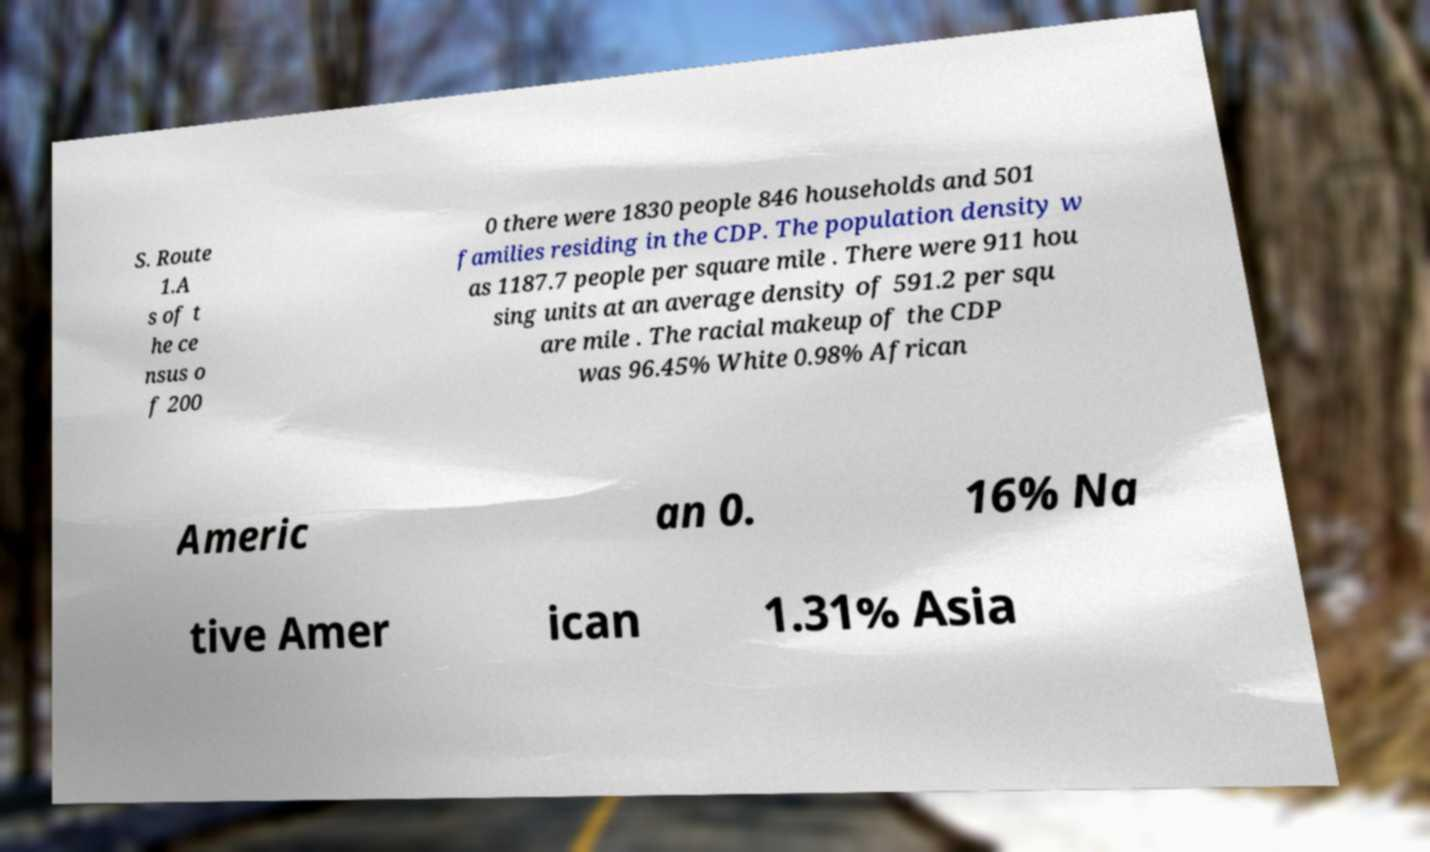Can you read and provide the text displayed in the image?This photo seems to have some interesting text. Can you extract and type it out for me? S. Route 1.A s of t he ce nsus o f 200 0 there were 1830 people 846 households and 501 families residing in the CDP. The population density w as 1187.7 people per square mile . There were 911 hou sing units at an average density of 591.2 per squ are mile . The racial makeup of the CDP was 96.45% White 0.98% African Americ an 0. 16% Na tive Amer ican 1.31% Asia 